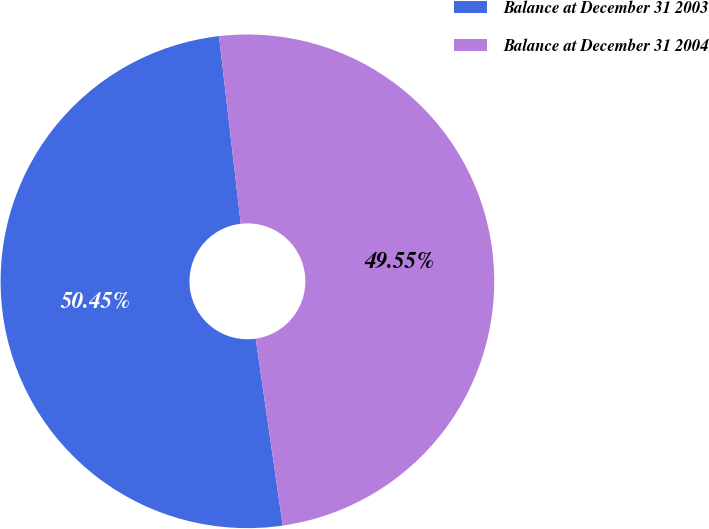<chart> <loc_0><loc_0><loc_500><loc_500><pie_chart><fcel>Balance at December 31 2003<fcel>Balance at December 31 2004<nl><fcel>50.45%<fcel>49.55%<nl></chart> 